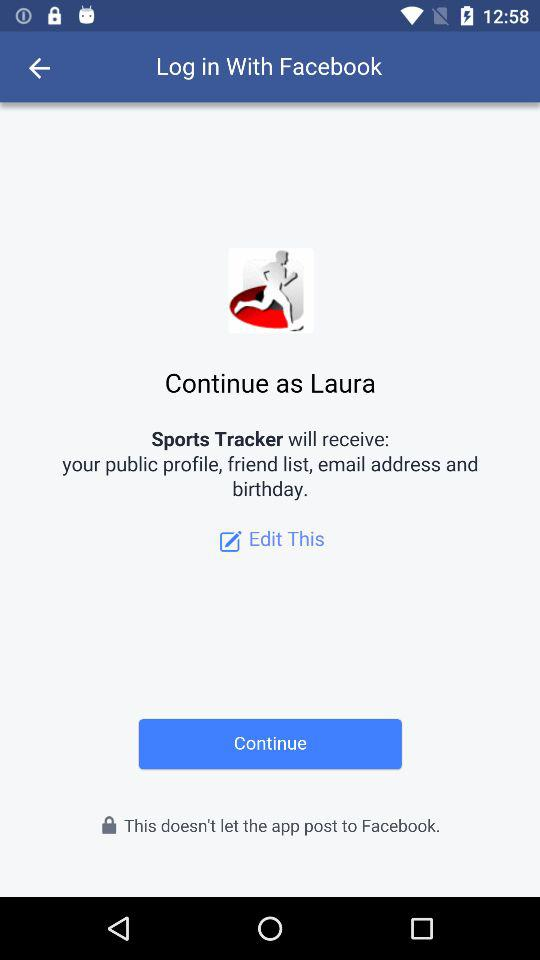What is the user name? The user name is Laura. 